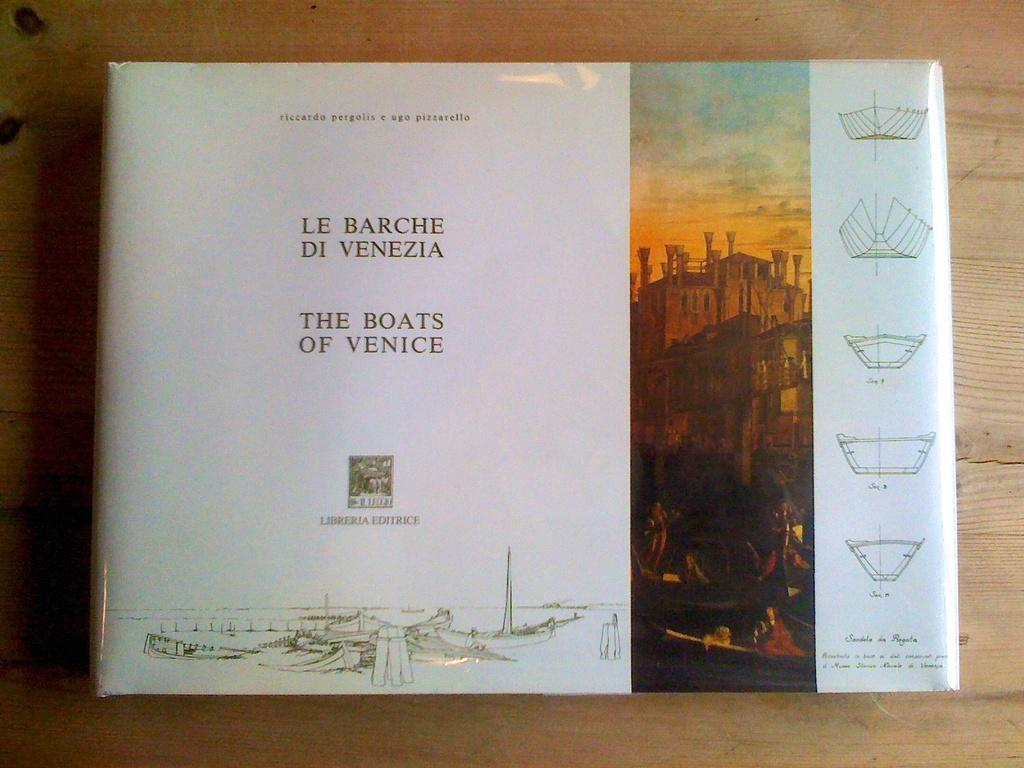<image>
Provide a brief description of the given image. A hardcover book about the boats of venice has a glossy paper cover. 